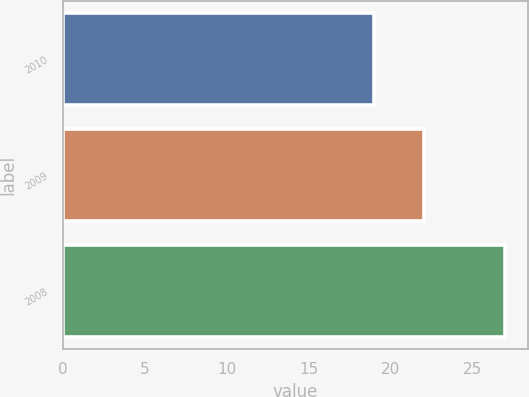Convert chart to OTSL. <chart><loc_0><loc_0><loc_500><loc_500><bar_chart><fcel>2010<fcel>2009<fcel>2008<nl><fcel>19<fcel>22<fcel>27<nl></chart> 